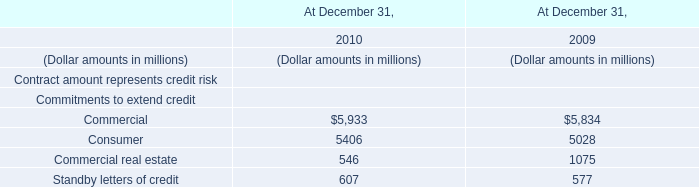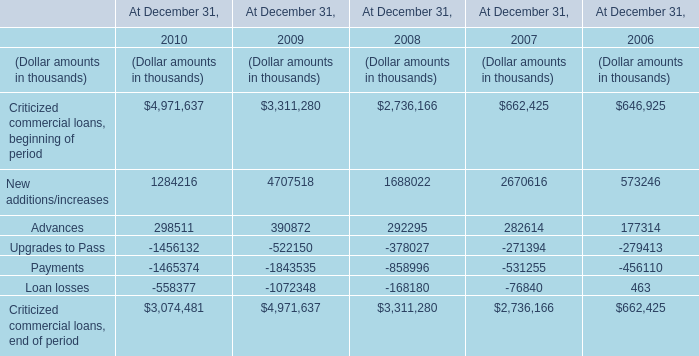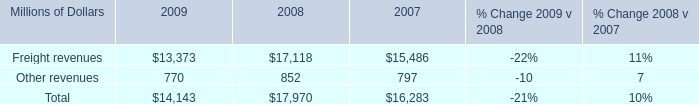What was the average of the Upgrades to Pass in the years where Advances is positive? (in thousand) 
Computations: (((((-1456132 - 522150) - 378027) - 271394) - 279413) / 5)
Answer: -581423.2. 